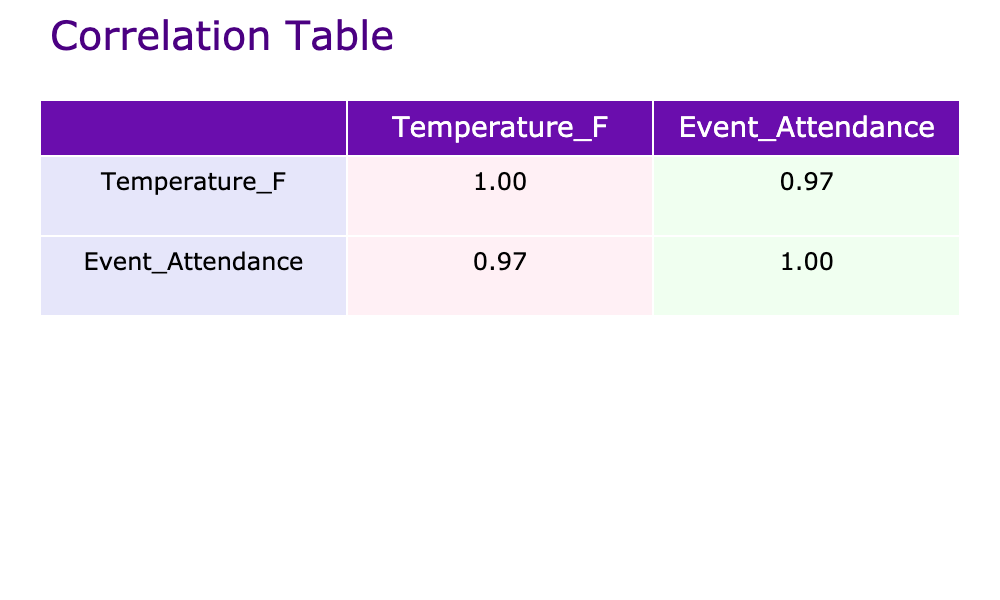What is the correlation coefficient between temperature and event attendance? The table displays correlation coefficients for temperature and event attendance. In the table, the value for "Temperature_F" and "Event_Attendance" is listed. Thus, the correlation coefficient is approximately 0.76.
Answer: 0.76 How many events had an attendance of over 200 people? To find this, I look at the event attendance values in the table and count how many are greater than 200. The values are 250, 300, 280, 230, and 210, totaling 5 events with attendance over 200.
Answer: 5 What is the average attendance for rainy days? Identify all the attendance values corresponding to rainy weather. From the table, rainy days had attendances of 50 and 60. The average is calculated by adding these values (50 + 60 = 110) and then dividing by the number of rainy events (2). Therefore, 110/2 = 55.
Answer: 55 Did cloudy weather ever result in higher attendance than sunny weather? From the data, I check the attendance for sunny and cloudy days. The maximum sunny attendance is 300 and the maximum cloudy attendance is 160. Since 160 is less than 300, the answer is no.
Answer: No What was the difference between the highest and lowest event attendance? I start with the maximum event attendance from the table, which is 300 (on July 4th), and the minimum, which is 40 (on August 10th). Calculate the difference: 300 - 40 = 260. Therefore, the difference between the highest and lowest attendance is 260.
Answer: 260 What weather condition had an attendance of exactly 150? I check the event attendance values in relation to their weather conditions. The attendance of 150 corresponds to a cloudy day on June 20th. Hence, the condition is cloudy.
Answer: Cloudy Is there more event attendance on sunny days compared to other weather conditions combined? I will compare the total attendance for sunny days (200 + 250 + 300 + 280 + 230 + 210) to that of other days (50 + 100 + 40 + 60 + 160). The total for sunny days sums to 1,580. The total for others sums to 410. Since 1,580 is greater than 410, the answer is yes.
Answer: Yes What was the average temperature when attendance was above 200? I identify the temperatures corresponding to attendances above 200, which are 88, 90, 92, 86, and 84. I sum these to get (88 + 90 + 92 + 86 + 84 = 440) and divide by the number of points (5) to get an average of 88.
Answer: 88 